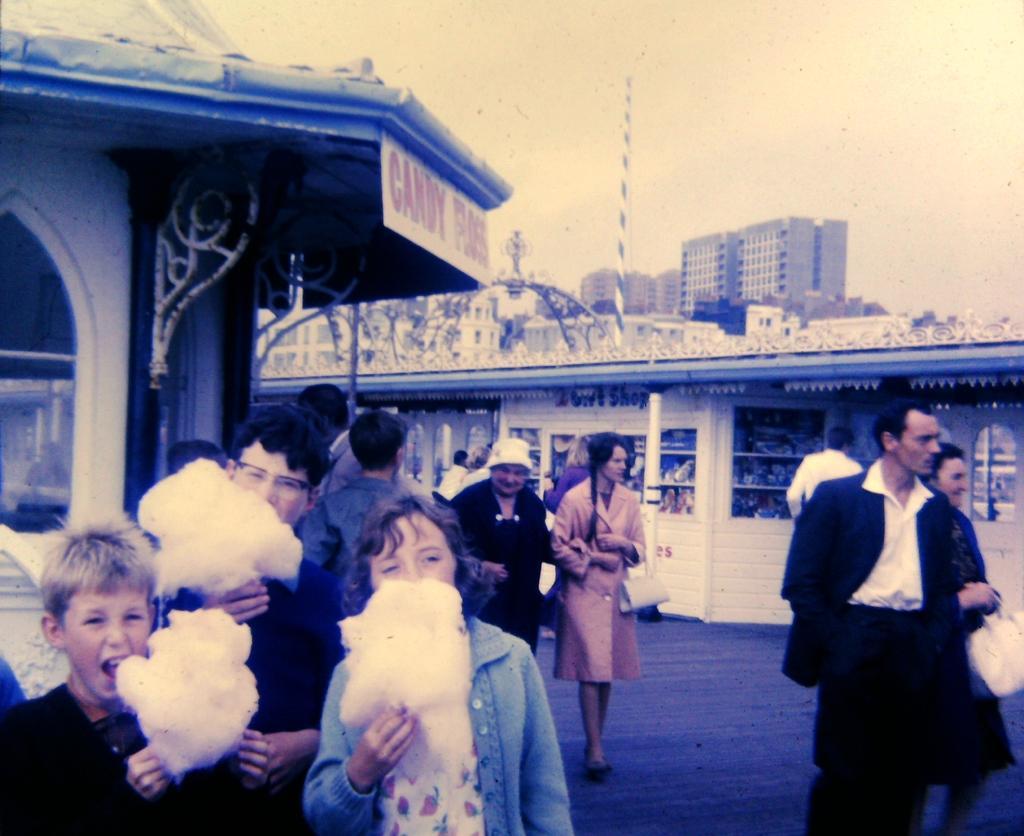How would you summarize this image in a sentence or two? In the image there are many people walking on the land, on the left side there are three people eating cotton candy, in the back there are buildings and above its sky. 